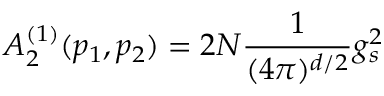Convert formula to latex. <formula><loc_0><loc_0><loc_500><loc_500>A _ { 2 } ^ { ( 1 ) } ( p _ { 1 } , p _ { 2 } ) = 2 N \frac { 1 } { ( 4 \pi ) ^ { d / 2 } } g _ { s } ^ { 2 }</formula> 